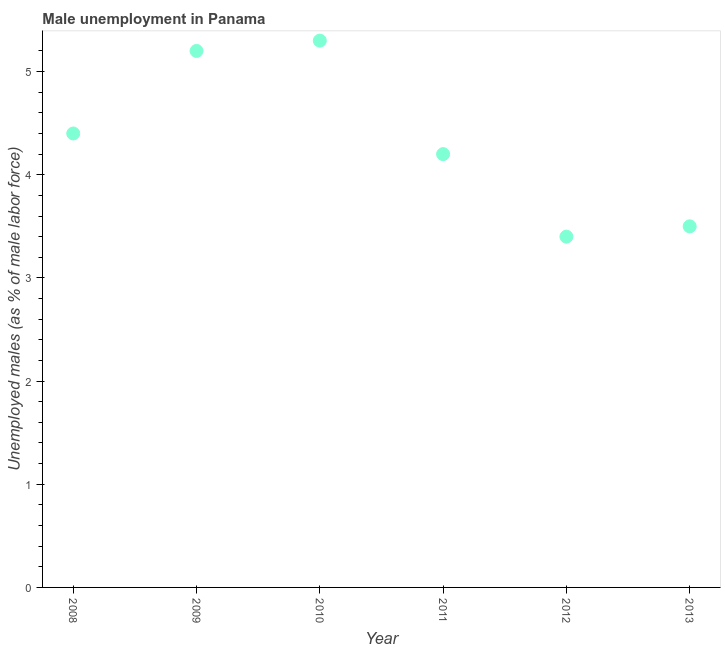What is the unemployed males population in 2008?
Your answer should be very brief. 4.4. Across all years, what is the maximum unemployed males population?
Your answer should be very brief. 5.3. Across all years, what is the minimum unemployed males population?
Your answer should be very brief. 3.4. In which year was the unemployed males population minimum?
Keep it short and to the point. 2012. What is the difference between the unemployed males population in 2011 and 2013?
Provide a succinct answer. 0.7. What is the average unemployed males population per year?
Provide a succinct answer. 4.33. What is the median unemployed males population?
Your response must be concise. 4.3. In how many years, is the unemployed males population greater than 5 %?
Make the answer very short. 2. What is the ratio of the unemployed males population in 2010 to that in 2012?
Give a very brief answer. 1.56. Is the difference between the unemployed males population in 2009 and 2010 greater than the difference between any two years?
Provide a succinct answer. No. What is the difference between the highest and the second highest unemployed males population?
Your response must be concise. 0.1. Is the sum of the unemployed males population in 2008 and 2013 greater than the maximum unemployed males population across all years?
Make the answer very short. Yes. What is the difference between the highest and the lowest unemployed males population?
Provide a succinct answer. 1.9. In how many years, is the unemployed males population greater than the average unemployed males population taken over all years?
Your answer should be compact. 3. How many years are there in the graph?
Provide a succinct answer. 6. What is the difference between two consecutive major ticks on the Y-axis?
Ensure brevity in your answer.  1. Are the values on the major ticks of Y-axis written in scientific E-notation?
Your response must be concise. No. What is the title of the graph?
Offer a terse response. Male unemployment in Panama. What is the label or title of the X-axis?
Ensure brevity in your answer.  Year. What is the label or title of the Y-axis?
Ensure brevity in your answer.  Unemployed males (as % of male labor force). What is the Unemployed males (as % of male labor force) in 2008?
Keep it short and to the point. 4.4. What is the Unemployed males (as % of male labor force) in 2009?
Make the answer very short. 5.2. What is the Unemployed males (as % of male labor force) in 2010?
Offer a very short reply. 5.3. What is the Unemployed males (as % of male labor force) in 2011?
Offer a terse response. 4.2. What is the Unemployed males (as % of male labor force) in 2012?
Your response must be concise. 3.4. What is the Unemployed males (as % of male labor force) in 2013?
Keep it short and to the point. 3.5. What is the difference between the Unemployed males (as % of male labor force) in 2008 and 2012?
Offer a very short reply. 1. What is the difference between the Unemployed males (as % of male labor force) in 2008 and 2013?
Offer a very short reply. 0.9. What is the difference between the Unemployed males (as % of male labor force) in 2009 and 2010?
Ensure brevity in your answer.  -0.1. What is the difference between the Unemployed males (as % of male labor force) in 2009 and 2011?
Ensure brevity in your answer.  1. What is the difference between the Unemployed males (as % of male labor force) in 2009 and 2012?
Provide a short and direct response. 1.8. What is the difference between the Unemployed males (as % of male labor force) in 2010 and 2012?
Offer a terse response. 1.9. What is the difference between the Unemployed males (as % of male labor force) in 2010 and 2013?
Your response must be concise. 1.8. What is the difference between the Unemployed males (as % of male labor force) in 2012 and 2013?
Offer a terse response. -0.1. What is the ratio of the Unemployed males (as % of male labor force) in 2008 to that in 2009?
Your answer should be compact. 0.85. What is the ratio of the Unemployed males (as % of male labor force) in 2008 to that in 2010?
Offer a very short reply. 0.83. What is the ratio of the Unemployed males (as % of male labor force) in 2008 to that in 2011?
Your answer should be compact. 1.05. What is the ratio of the Unemployed males (as % of male labor force) in 2008 to that in 2012?
Ensure brevity in your answer.  1.29. What is the ratio of the Unemployed males (as % of male labor force) in 2008 to that in 2013?
Offer a very short reply. 1.26. What is the ratio of the Unemployed males (as % of male labor force) in 2009 to that in 2011?
Offer a very short reply. 1.24. What is the ratio of the Unemployed males (as % of male labor force) in 2009 to that in 2012?
Ensure brevity in your answer.  1.53. What is the ratio of the Unemployed males (as % of male labor force) in 2009 to that in 2013?
Provide a short and direct response. 1.49. What is the ratio of the Unemployed males (as % of male labor force) in 2010 to that in 2011?
Your answer should be compact. 1.26. What is the ratio of the Unemployed males (as % of male labor force) in 2010 to that in 2012?
Your answer should be compact. 1.56. What is the ratio of the Unemployed males (as % of male labor force) in 2010 to that in 2013?
Ensure brevity in your answer.  1.51. What is the ratio of the Unemployed males (as % of male labor force) in 2011 to that in 2012?
Keep it short and to the point. 1.24. 